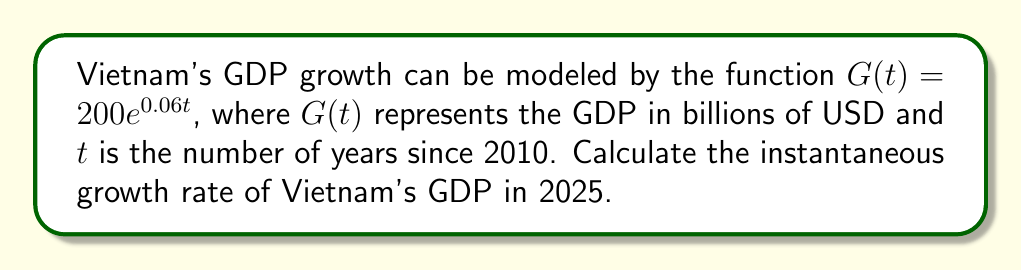Give your solution to this math problem. To solve this problem, we'll follow these steps:

1) The instantaneous growth rate is given by the derivative of the function divided by the function itself. In mathematical terms:

   Growth Rate = $\frac{G'(t)}{G(t)}$

2) First, let's find $G'(t)$:
   $G(t) = 200e^{0.06t}$
   $G'(t) = 200 \cdot 0.06e^{0.06t} = 12e^{0.06t}$

3) Now we can set up our growth rate equation:
   Growth Rate = $\frac{G'(t)}{G(t)} = \frac{12e^{0.06t}}{200e^{0.06t}} = \frac{12}{200} = 0.06$

4) Notice that this rate is constant and doesn't depend on $t$. This is a property of exponential functions.

5) Therefore, the instantaneous growth rate in 2025 (or any other year) is 0.06 or 6%.

6) To express this as a percentage, we multiply by 100:
   0.06 * 100 = 6%
Answer: 6% 